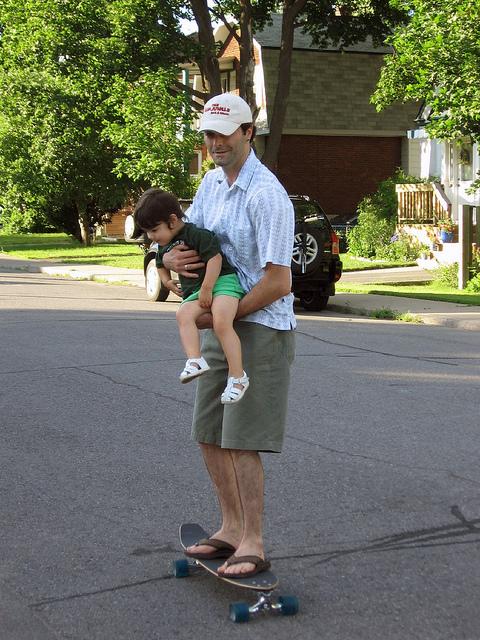Is this his first time on a skateboard?
Give a very brief answer. No. Is he teaching the child to skateboard?
Write a very short answer. No. What kind of shoes is this person wearing?
Answer briefly. Sandals. Do you think this is a safe way to transport a child?
Quick response, please. No. How many wheels of the skateboard are touching the ground?
Quick response, please. 4. Is this man wearing skateboarding shoes?
Give a very brief answer. No. Is this a public tennis court?
Answer briefly. No. What type of trees are here?
Short answer required. Oak. Is the man's hat on backwards or forwards?
Give a very brief answer. Forwards. What is on the back of the skater?
Quick response, please. Shirt. Is the vegetation tropical?
Be succinct. No. What is the person holding?
Write a very short answer. Child. Is the man on the skateboard wearing skate shoes?
Answer briefly. No. Is there a stop sign?
Write a very short answer. No. What trick is this?
Be succinct. No trick. 